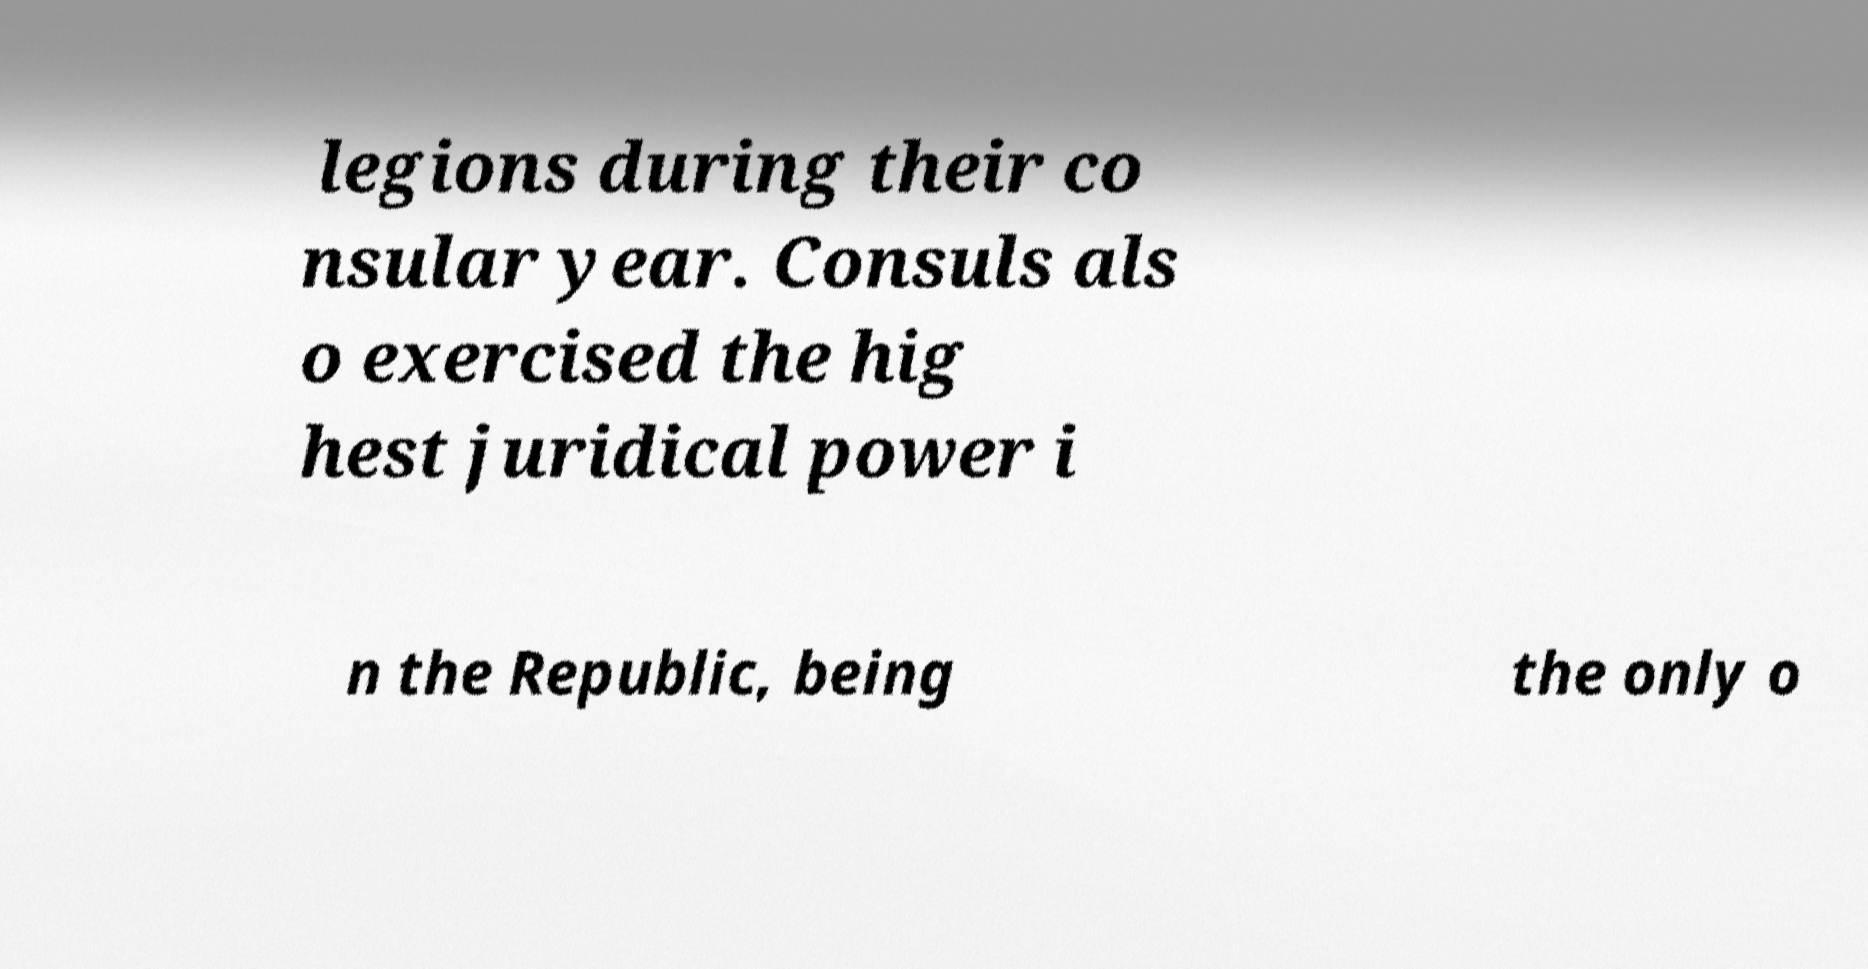There's text embedded in this image that I need extracted. Can you transcribe it verbatim? legions during their co nsular year. Consuls als o exercised the hig hest juridical power i n the Republic, being the only o 